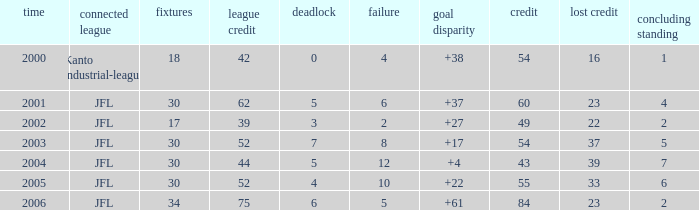Tell me the highest point with lost point being 33 and league point less than 52 None. Can you parse all the data within this table? {'header': ['time', 'connected league', 'fixtures', 'league credit', 'deadlock', 'failure', 'goal disparity', 'credit', 'lost credit', 'concluding standing'], 'rows': [['2000', 'Kanto industrial-league', '18', '42', '0', '4', '+38', '54', '16', '1'], ['2001', 'JFL', '30', '62', '5', '6', '+37', '60', '23', '4'], ['2002', 'JFL', '17', '39', '3', '2', '+27', '49', '22', '2'], ['2003', 'JFL', '30', '52', '7', '8', '+17', '54', '37', '5'], ['2004', 'JFL', '30', '44', '5', '12', '+4', '43', '39', '7'], ['2005', 'JFL', '30', '52', '4', '10', '+22', '55', '33', '6'], ['2006', 'JFL', '34', '75', '6', '5', '+61', '84', '23', '2']]} 